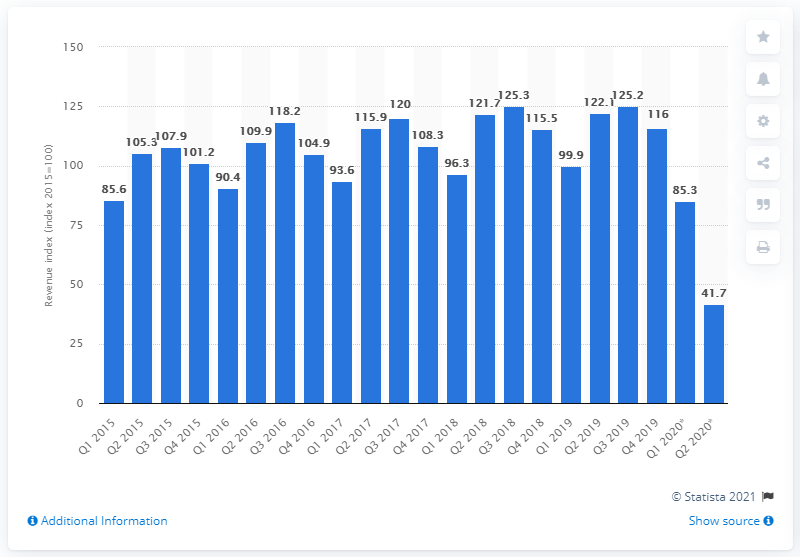Highlight a few significant elements in this photo. The revenue index for the coffee industry in the second quarter of 2020 was 41.7. According to the revenue index of the Dutch caf industry in the first quarter of 2020, the revenue was 85.3%. 